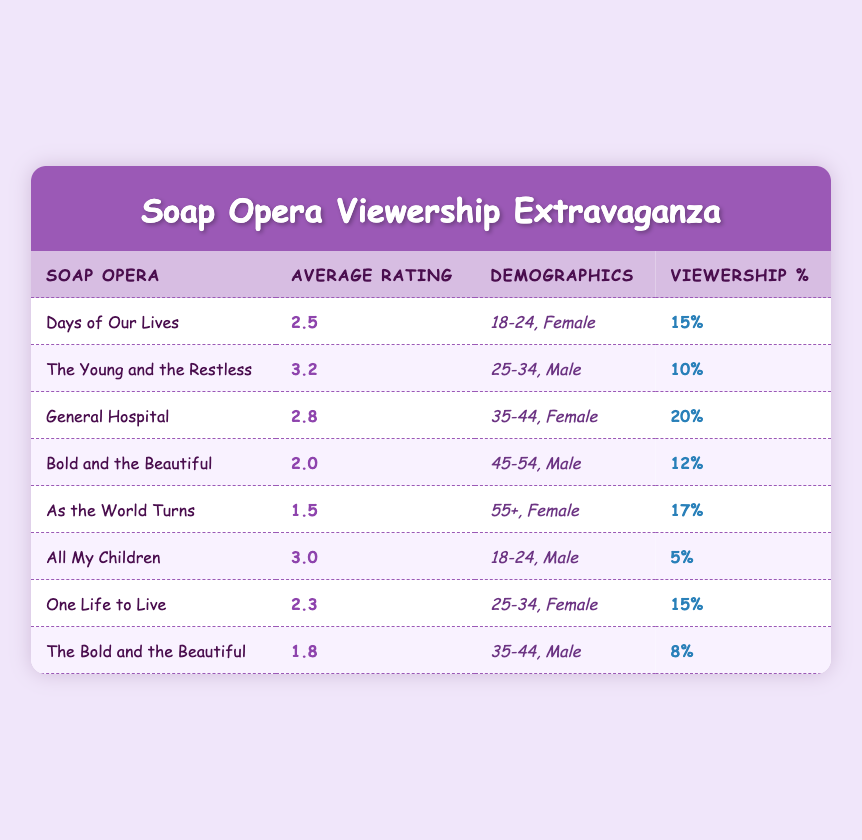What is the average rating of "Days of Our Lives"? The table shows that the average rating for "Days of Our Lives" is 2.5, found directly in the "Average Rating" column corresponding to that title.
Answer: 2.5 What percentage of viewership does "General Hospital" have among females aged 35-44? According to the table, "General Hospital" has a viewership percentage of 20% for the demographic of females aged 35-44, as listed in the relevant row.
Answer: 20% Which soap opera has the highest average rating? The average ratings listed show that "The Young and the Restless" has the highest average rating of 3.2. This is the highest value found in the "Average Rating" column.
Answer: The Young and the Restless Is "As the World Turns" more popular than "Bold and the Beautiful" among the 55+ female demographic? "As the World Turns" has a viewership percentage of 17% among females aged 55+, while "Bold and the Beautiful" doesn't cater to this demographic based on the data provided, thus verifying that "As the World Turns" is indeed more popular in that context.
Answer: Yes What is the total viewership percentage for soap operas watched by males aged 25-34? From the table, the viewership percentage for males aged 25-34 is 10% for "The Young and the Restless" and 15% for "One Life to Live." Adding these gives a total of 10% + 15% = 25%.
Answer: 25% Which demographic has the lowest average rating soap opera? Upon reviewing the average ratings, "As the World Turns" has the lowest average rating of 1.5 among females aged 55+, which is less than any other average rating shown in the table.
Answer: As the World Turns Is it true that all soap operas targeted at females aged 35-44 have an average rating above 2.0? Looking at the table, "Bold and the Beautiful" targeted at males aged 35-44 has an average rating of 1.8, indicating that it is not above 2.0. Therefore, the statement is false.
Answer: No Which soap opera has a lower viewership percentage among males aged 18-24, "Days of Our Lives" or "All My Children"? "Days of Our Lives" has a viewership percentage of 15% for females aged 18-24, whereas "All My Children" caters to males aged 18-24 with a percentage of only 5%. Comparing these figures shows that "All My Children" has lower viewership among males aged 18-24.
Answer: All My Children 